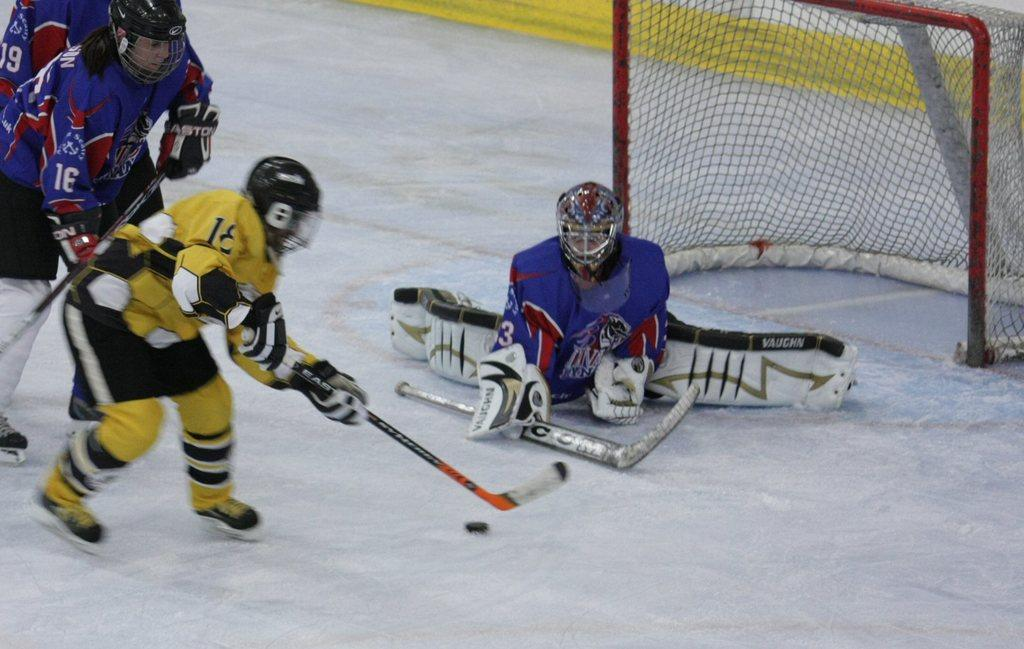How many people are playing ice hockey in the image? There are four persons in the image. What are the players doing in the image? The persons are playing ice hockey. On what surface is the game being played? The game is being played on ice. What equipment are the players using to play ice hockey? The players are holding hockey sticks. What is the goal of the game in the image? There is a hockey net in the image, which is the target for scoring goals. What type of design can be seen on the bun in the image? There is no bun present in the image; it features four persons playing ice hockey on ice. 